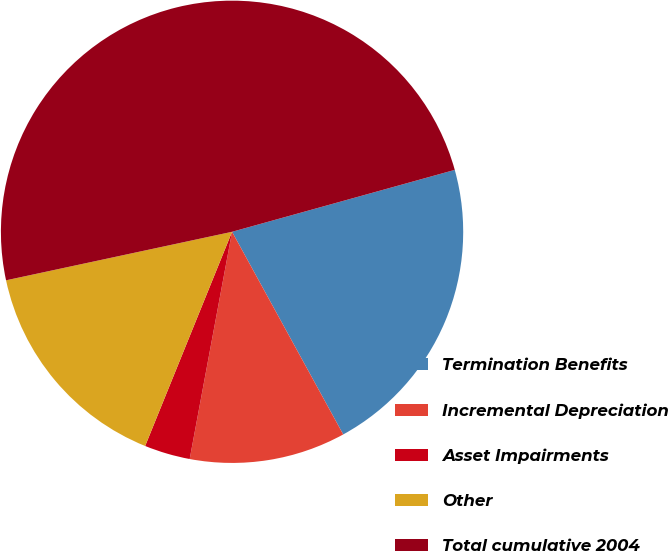<chart> <loc_0><loc_0><loc_500><loc_500><pie_chart><fcel>Termination Benefits<fcel>Incremental Depreciation<fcel>Asset Impairments<fcel>Other<fcel>Total cumulative 2004<nl><fcel>21.33%<fcel>10.92%<fcel>3.2%<fcel>15.5%<fcel>49.05%<nl></chart> 